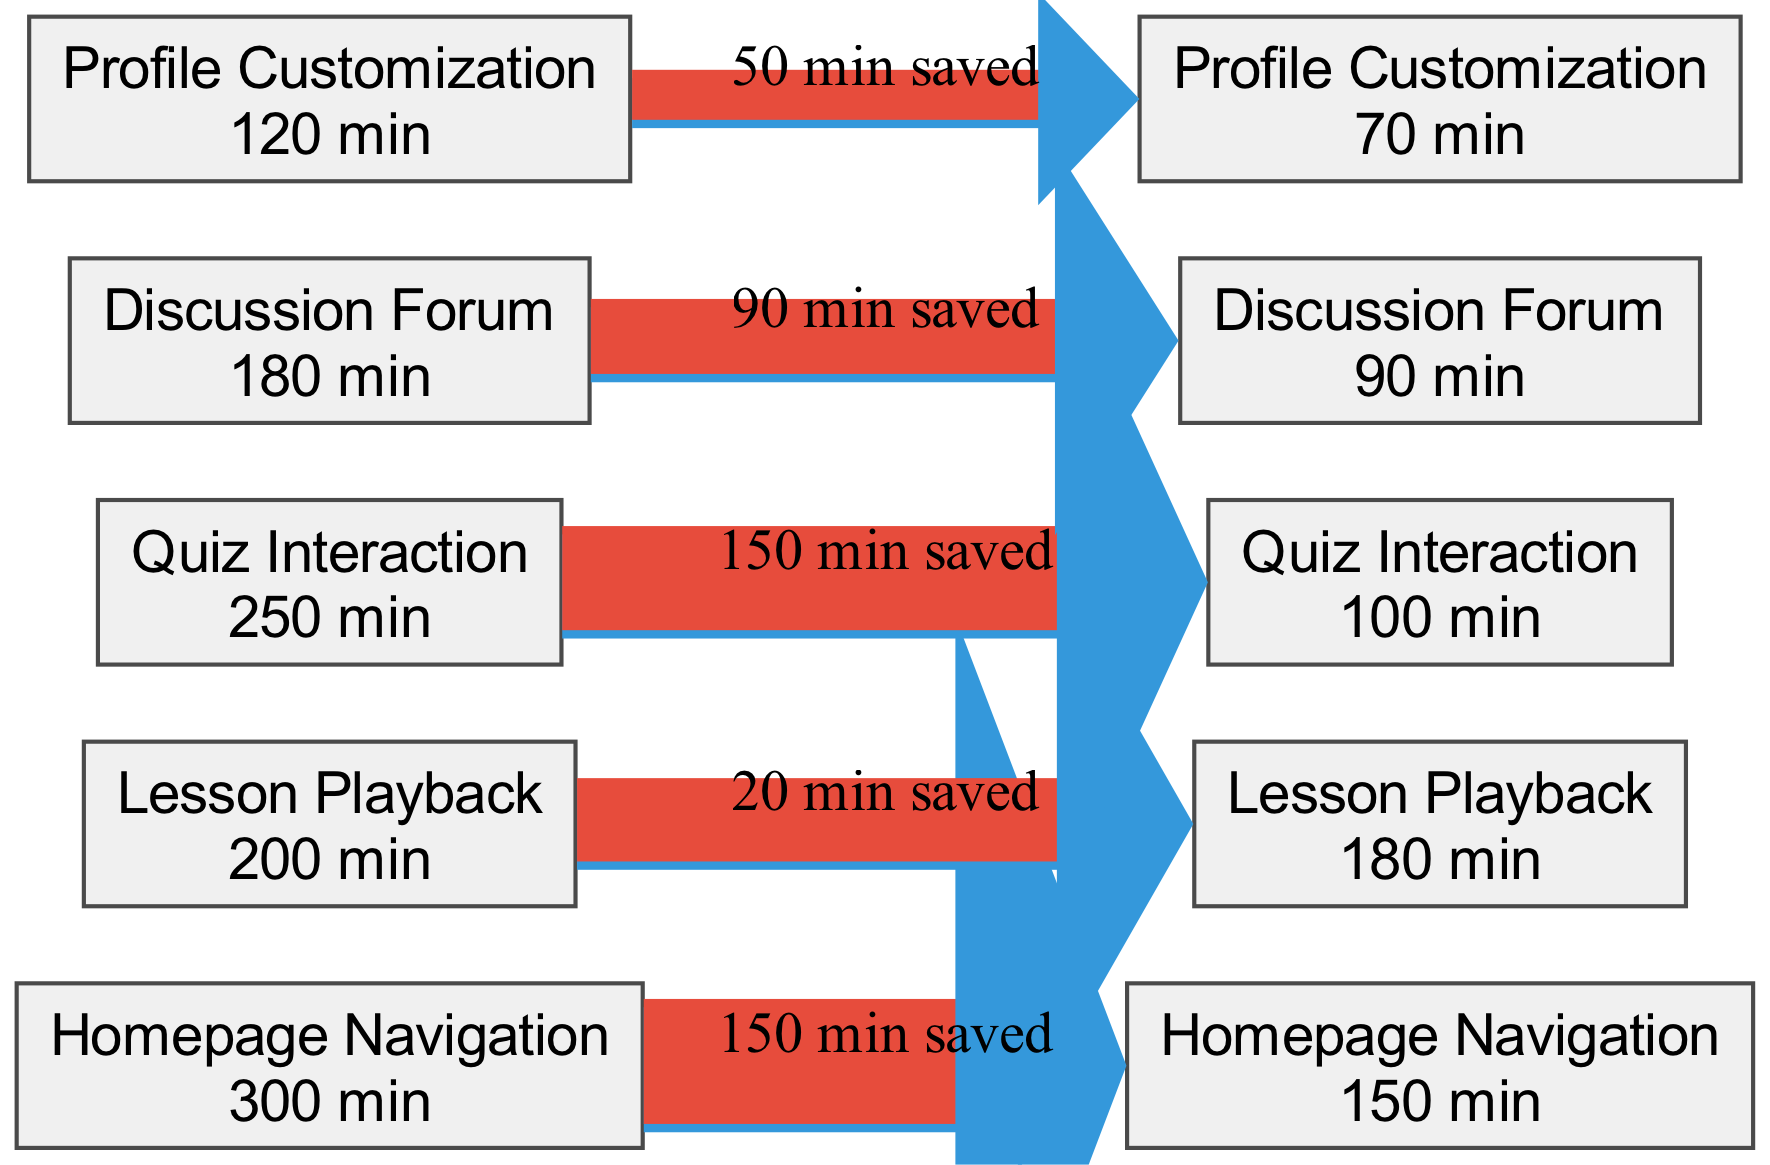What is the total time spent on Homepage Navigation before redesign? The diagram indicates that the time spent on Homepage Navigation before the redesign is 300 minutes. This value is directly indicated in the node associated with Homepage Navigation under the "before" section.
Answer: 300 minutes What was the time saved for Quiz Interaction after the redesign? By analyzing the times indicated for Quiz Interaction, it shows that before redesign it was 250 minutes and after redesign it was 100 minutes. The time saved can be calculated as 250 - 100 which equals 150 minutes.
Answer: 150 minutes How many features are shown in the diagram? The information provided in the dataset indicates there are five features listed: Homepage Navigation, Lesson Playback, Quiz Interaction, Discussion Forum, and Profile Customization. Therefore, the total number of features displayed in the diagram is five.
Answer: 5 What is the time spent on Profile Customization after the redesign? Referring to the specific node for Profile Customization after the redesign, it shows that the time spent is 70 minutes. This information is presented in the relevant "after" section of the diagram.
Answer: 70 minutes Which feature had the highest time spent before the redesign? By reviewing the "before" section of all features, Homepage Navigation has the highest time spent before the redesign at 300 minutes, compared to other features with lesser times.
Answer: Homepage Navigation What is the difference in time spent on Discussion Forum before and after the redesign? The time for Discussion Forum before redesign is 180 minutes and after redesign it is 90 minutes. To find the difference, subtract 90 from 180, resulting in 90 minutes.
Answer: 90 minutes Which feature had the lowest time spent after the redesign? Examining the "after" times for each feature, Profile Customization has the lowest time spent at 70 minutes, which is the smallest value compared to the others in that section.
Answer: Profile Customization How much total time was saved across all features after the redesign? To find the total time saved, sum up the individual time savings from each feature: (300-150) + (200-180) + (250-100) + (180-90) + (120-70) equals 322 minutes saved in total.
Answer: 322 minutes What is the time spent on Lesson Playback before the redesign? The diagram presents the data indicating that the time spent on Lesson Playback before the redesign is 200 minutes, which can be seen in the corresponding node.
Answer: 200 minutes 